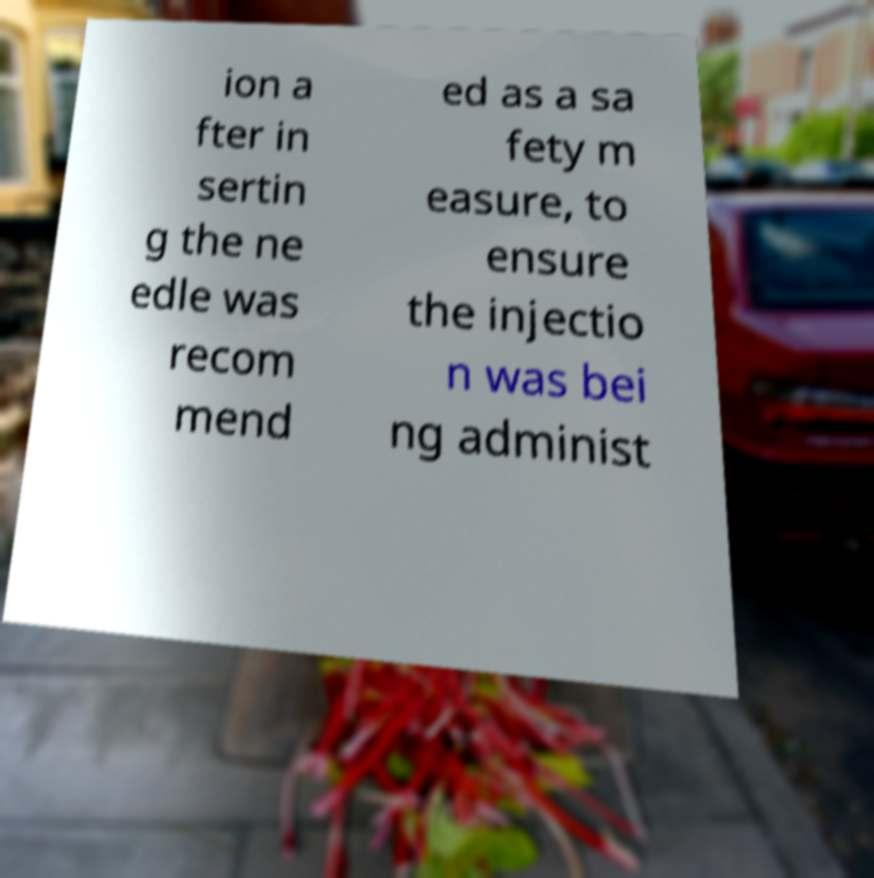There's text embedded in this image that I need extracted. Can you transcribe it verbatim? ion a fter in sertin g the ne edle was recom mend ed as a sa fety m easure, to ensure the injectio n was bei ng administ 